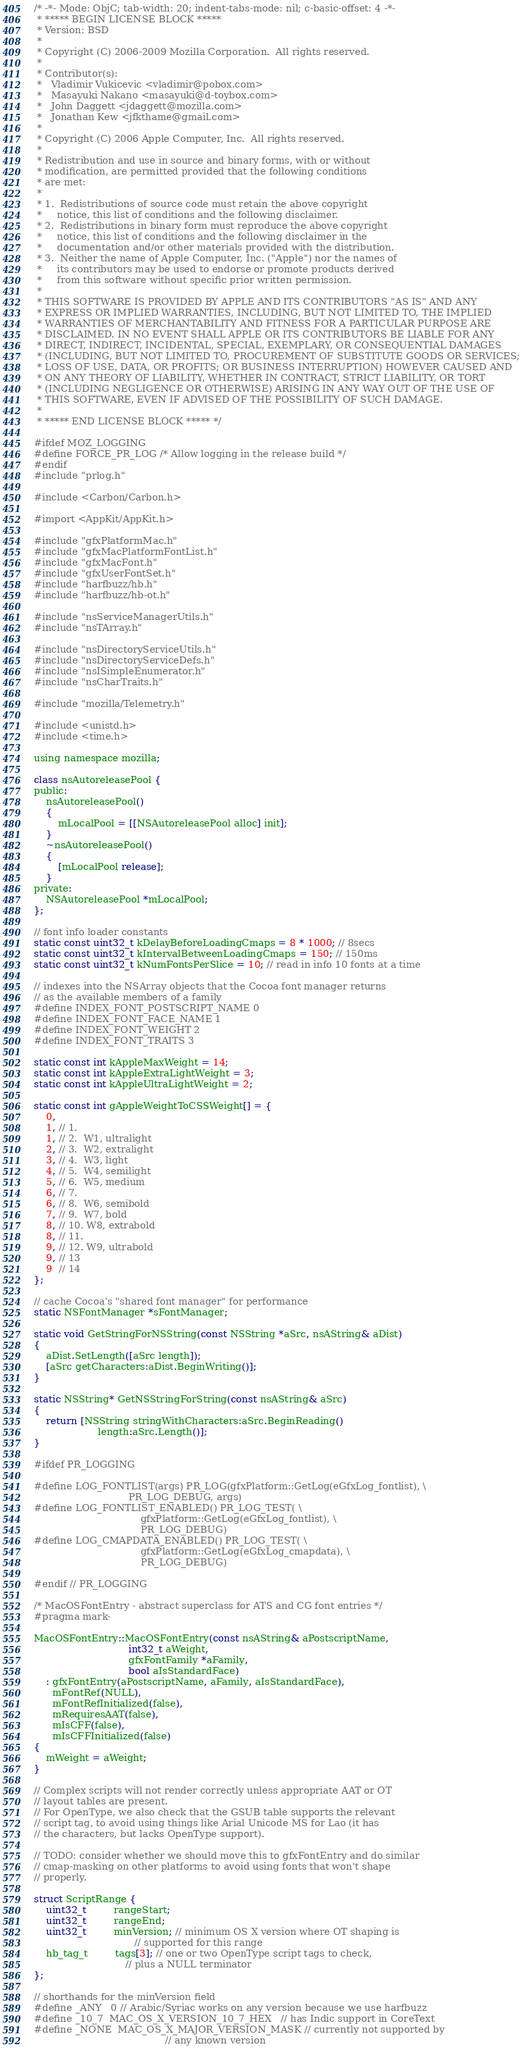<code> <loc_0><loc_0><loc_500><loc_500><_ObjectiveC_>/* -*- Mode: ObjC; tab-width: 20; indent-tabs-mode: nil; c-basic-offset: 4 -*-
 * ***** BEGIN LICENSE BLOCK *****
 * Version: BSD
 *
 * Copyright (C) 2006-2009 Mozilla Corporation.  All rights reserved.
 *
 * Contributor(s):
 *   Vladimir Vukicevic <vladimir@pobox.com>
 *   Masayuki Nakano <masayuki@d-toybox.com>
 *   John Daggett <jdaggett@mozilla.com>
 *   Jonathan Kew <jfkthame@gmail.com>
 *
 * Copyright (C) 2006 Apple Computer, Inc.  All rights reserved.
 *
 * Redistribution and use in source and binary forms, with or without
 * modification, are permitted provided that the following conditions
 * are met:
 *
 * 1.  Redistributions of source code must retain the above copyright
 *     notice, this list of conditions and the following disclaimer.
 * 2.  Redistributions in binary form must reproduce the above copyright
 *     notice, this list of conditions and the following disclaimer in the
 *     documentation and/or other materials provided with the distribution.
 * 3.  Neither the name of Apple Computer, Inc. ("Apple") nor the names of
 *     its contributors may be used to endorse or promote products derived
 *     from this software without specific prior written permission.
 *
 * THIS SOFTWARE IS PROVIDED BY APPLE AND ITS CONTRIBUTORS "AS IS" AND ANY
 * EXPRESS OR IMPLIED WARRANTIES, INCLUDING, BUT NOT LIMITED TO, THE IMPLIED
 * WARRANTIES OF MERCHANTABILITY AND FITNESS FOR A PARTICULAR PURPOSE ARE
 * DISCLAIMED. IN NO EVENT SHALL APPLE OR ITS CONTRIBUTORS BE LIABLE FOR ANY
 * DIRECT, INDIRECT, INCIDENTAL, SPECIAL, EXEMPLARY, OR CONSEQUENTIAL DAMAGES
 * (INCLUDING, BUT NOT LIMITED TO, PROCUREMENT OF SUBSTITUTE GOODS OR SERVICES;
 * LOSS OF USE, DATA, OR PROFITS; OR BUSINESS INTERRUPTION) HOWEVER CAUSED AND
 * ON ANY THEORY OF LIABILITY, WHETHER IN CONTRACT, STRICT LIABILITY, OR TORT
 * (INCLUDING NEGLIGENCE OR OTHERWISE) ARISING IN ANY WAY OUT OF THE USE OF
 * THIS SOFTWARE, EVEN IF ADVISED OF THE POSSIBILITY OF SUCH DAMAGE.
 *
 * ***** END LICENSE BLOCK ***** */

#ifdef MOZ_LOGGING
#define FORCE_PR_LOG /* Allow logging in the release build */
#endif
#include "prlog.h"

#include <Carbon/Carbon.h>

#import <AppKit/AppKit.h>

#include "gfxPlatformMac.h"
#include "gfxMacPlatformFontList.h"
#include "gfxMacFont.h"
#include "gfxUserFontSet.h"
#include "harfbuzz/hb.h"
#include "harfbuzz/hb-ot.h"

#include "nsServiceManagerUtils.h"
#include "nsTArray.h"

#include "nsDirectoryServiceUtils.h"
#include "nsDirectoryServiceDefs.h"
#include "nsISimpleEnumerator.h"
#include "nsCharTraits.h"

#include "mozilla/Telemetry.h"

#include <unistd.h>
#include <time.h>

using namespace mozilla;

class nsAutoreleasePool {
public:
    nsAutoreleasePool()
    {
        mLocalPool = [[NSAutoreleasePool alloc] init];
    }
    ~nsAutoreleasePool()
    {
        [mLocalPool release];
    }
private:
    NSAutoreleasePool *mLocalPool;
};

// font info loader constants
static const uint32_t kDelayBeforeLoadingCmaps = 8 * 1000; // 8secs
static const uint32_t kIntervalBetweenLoadingCmaps = 150; // 150ms
static const uint32_t kNumFontsPerSlice = 10; // read in info 10 fonts at a time

// indexes into the NSArray objects that the Cocoa font manager returns
// as the available members of a family
#define INDEX_FONT_POSTSCRIPT_NAME 0
#define INDEX_FONT_FACE_NAME 1
#define INDEX_FONT_WEIGHT 2
#define INDEX_FONT_TRAITS 3

static const int kAppleMaxWeight = 14;
static const int kAppleExtraLightWeight = 3;
static const int kAppleUltraLightWeight = 2;

static const int gAppleWeightToCSSWeight[] = {
    0,
    1, // 1.
    1, // 2.  W1, ultralight
    2, // 3.  W2, extralight
    3, // 4.  W3, light
    4, // 5.  W4, semilight
    5, // 6.  W5, medium
    6, // 7.
    6, // 8.  W6, semibold
    7, // 9.  W7, bold
    8, // 10. W8, extrabold
    8, // 11.
    9, // 12. W9, ultrabold
    9, // 13
    9  // 14
};

// cache Cocoa's "shared font manager" for performance
static NSFontManager *sFontManager;

static void GetStringForNSString(const NSString *aSrc, nsAString& aDist)
{
    aDist.SetLength([aSrc length]);
    [aSrc getCharacters:aDist.BeginWriting()];
}

static NSString* GetNSStringForString(const nsAString& aSrc)
{
    return [NSString stringWithCharacters:aSrc.BeginReading()
                     length:aSrc.Length()];
}

#ifdef PR_LOGGING

#define LOG_FONTLIST(args) PR_LOG(gfxPlatform::GetLog(eGfxLog_fontlist), \
                               PR_LOG_DEBUG, args)
#define LOG_FONTLIST_ENABLED() PR_LOG_TEST( \
                                   gfxPlatform::GetLog(eGfxLog_fontlist), \
                                   PR_LOG_DEBUG)
#define LOG_CMAPDATA_ENABLED() PR_LOG_TEST( \
                                   gfxPlatform::GetLog(eGfxLog_cmapdata), \
                                   PR_LOG_DEBUG)

#endif // PR_LOGGING

/* MacOSFontEntry - abstract superclass for ATS and CG font entries */
#pragma mark-

MacOSFontEntry::MacOSFontEntry(const nsAString& aPostscriptName,
                               int32_t aWeight,
                               gfxFontFamily *aFamily,
                               bool aIsStandardFace)
    : gfxFontEntry(aPostscriptName, aFamily, aIsStandardFace),
      mFontRef(NULL),
      mFontRefInitialized(false),
      mRequiresAAT(false),
      mIsCFF(false),
      mIsCFFInitialized(false)
{
    mWeight = aWeight;
}

// Complex scripts will not render correctly unless appropriate AAT or OT
// layout tables are present.
// For OpenType, we also check that the GSUB table supports the relevant
// script tag, to avoid using things like Arial Unicode MS for Lao (it has
// the characters, but lacks OpenType support).

// TODO: consider whether we should move this to gfxFontEntry and do similar
// cmap-masking on other platforms to avoid using fonts that won't shape
// properly.

struct ScriptRange {
    uint32_t         rangeStart;
    uint32_t         rangeEnd;
    uint32_t         minVersion; // minimum OS X version where OT shaping is
                                 // supported for this range
    hb_tag_t         tags[3]; // one or two OpenType script tags to check,
                              // plus a NULL terminator
};

// shorthands for the minVersion field
#define _ANY   0 // Arabic/Syriac works on any version because we use harfbuzz
#define _10_7  MAC_OS_X_VERSION_10_7_HEX   // has Indic support in CoreText
#define _NONE  MAC_OS_X_MAJOR_VERSION_MASK // currently not supported by
                                           // any known version
</code> 